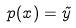<formula> <loc_0><loc_0><loc_500><loc_500>p ( x ) = \tilde { y }</formula> 